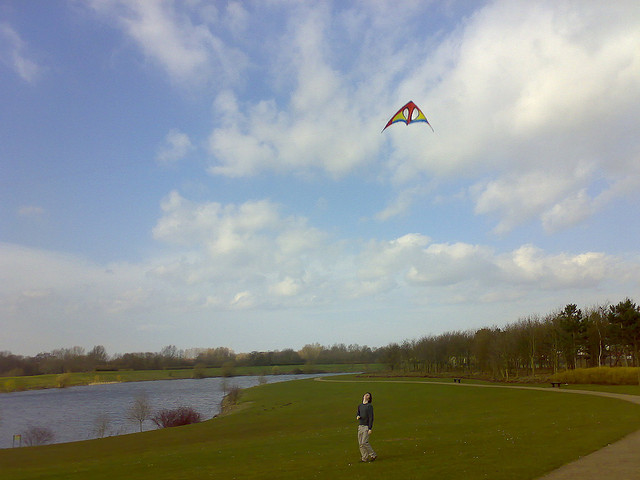Does the image suggest it is windy? Yes, the presence of the kite flying high and the person's stance holding onto the kite suggest a breeze is present, which is necessary for kite flying. Are there any other people or animals in the vicinity? No, the image shows a solitary figure engaging in kite flying. There are no other people or animals visible in the immediate surroundings. 